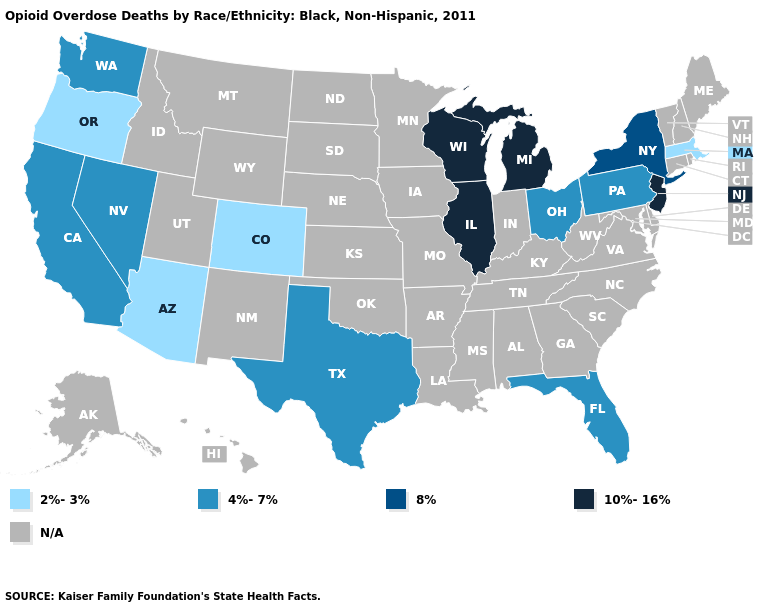What is the highest value in the MidWest ?
Give a very brief answer. 10%-16%. What is the value of Arkansas?
Write a very short answer. N/A. Name the states that have a value in the range 2%-3%?
Give a very brief answer. Arizona, Colorado, Massachusetts, Oregon. Name the states that have a value in the range 4%-7%?
Keep it brief. California, Florida, Nevada, Ohio, Pennsylvania, Texas, Washington. Name the states that have a value in the range 8%?
Short answer required. New York. Among the states that border Washington , which have the lowest value?
Give a very brief answer. Oregon. What is the value of Virginia?
Answer briefly. N/A. Name the states that have a value in the range 2%-3%?
Concise answer only. Arizona, Colorado, Massachusetts, Oregon. Does Colorado have the lowest value in the USA?
Give a very brief answer. Yes. What is the lowest value in the USA?
Give a very brief answer. 2%-3%. What is the value of Connecticut?
Be succinct. N/A. What is the lowest value in the Northeast?
Give a very brief answer. 2%-3%. 